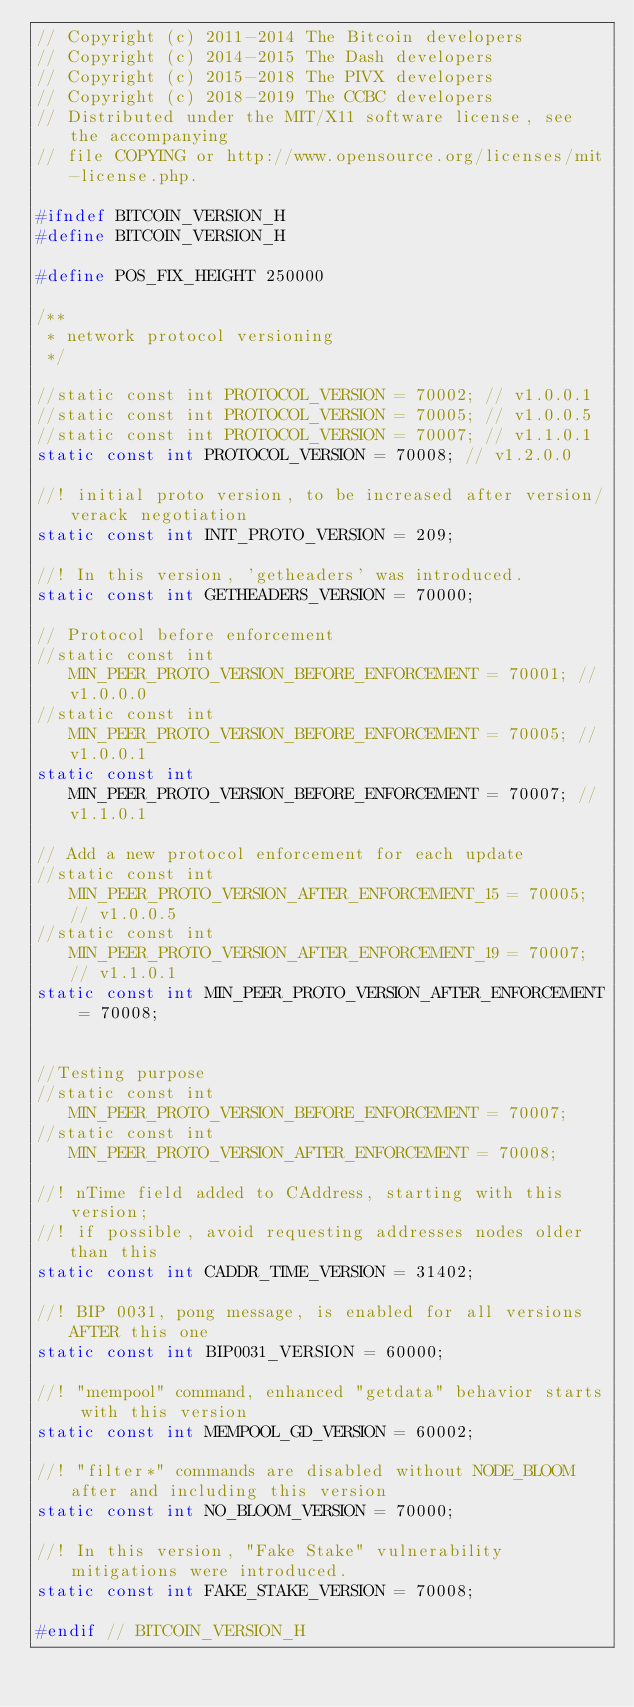<code> <loc_0><loc_0><loc_500><loc_500><_C_>// Copyright (c) 2011-2014 The Bitcoin developers
// Copyright (c) 2014-2015 The Dash developers
// Copyright (c) 2015-2018 The PIVX developers
// Copyright (c) 2018-2019 The CCBC developers
// Distributed under the MIT/X11 software license, see the accompanying
// file COPYING or http://www.opensource.org/licenses/mit-license.php.

#ifndef BITCOIN_VERSION_H
#define BITCOIN_VERSION_H

#define POS_FIX_HEIGHT 250000

/**
 * network protocol versioning
 */

//static const int PROTOCOL_VERSION = 70002; // v1.0.0.1
//static const int PROTOCOL_VERSION = 70005; // v1.0.0.5
//static const int PROTOCOL_VERSION = 70007; // v1.1.0.1
static const int PROTOCOL_VERSION = 70008; // v1.2.0.0

//! initial proto version, to be increased after version/verack negotiation
static const int INIT_PROTO_VERSION = 209;

//! In this version, 'getheaders' was introduced.
static const int GETHEADERS_VERSION = 70000;

// Protocol before enforcement
//static const int MIN_PEER_PROTO_VERSION_BEFORE_ENFORCEMENT = 70001; // v1.0.0.0
//static const int MIN_PEER_PROTO_VERSION_BEFORE_ENFORCEMENT = 70005; // v1.0.0.1
static const int MIN_PEER_PROTO_VERSION_BEFORE_ENFORCEMENT = 70007; // v1.1.0.1

// Add a new protocol enforcement for each update
//static const int MIN_PEER_PROTO_VERSION_AFTER_ENFORCEMENT_15 = 70005; // v1.0.0.5
//static const int MIN_PEER_PROTO_VERSION_AFTER_ENFORCEMENT_19 = 70007; // v1.1.0.1
static const int MIN_PEER_PROTO_VERSION_AFTER_ENFORCEMENT = 70008;


//Testing purpose
//static const int MIN_PEER_PROTO_VERSION_BEFORE_ENFORCEMENT = 70007;
//static const int MIN_PEER_PROTO_VERSION_AFTER_ENFORCEMENT = 70008;

//! nTime field added to CAddress, starting with this version;
//! if possible, avoid requesting addresses nodes older than this
static const int CADDR_TIME_VERSION = 31402;

//! BIP 0031, pong message, is enabled for all versions AFTER this one
static const int BIP0031_VERSION = 60000;

//! "mempool" command, enhanced "getdata" behavior starts with this version
static const int MEMPOOL_GD_VERSION = 60002;

//! "filter*" commands are disabled without NODE_BLOOM after and including this version
static const int NO_BLOOM_VERSION = 70000;

//! In this version, "Fake Stake" vulnerability mitigations were introduced.
static const int FAKE_STAKE_VERSION = 70008;

#endif // BITCOIN_VERSION_H
</code> 